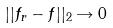Convert formula to latex. <formula><loc_0><loc_0><loc_500><loc_500>| | f _ { r } - f | | _ { 2 } \rightarrow 0</formula> 